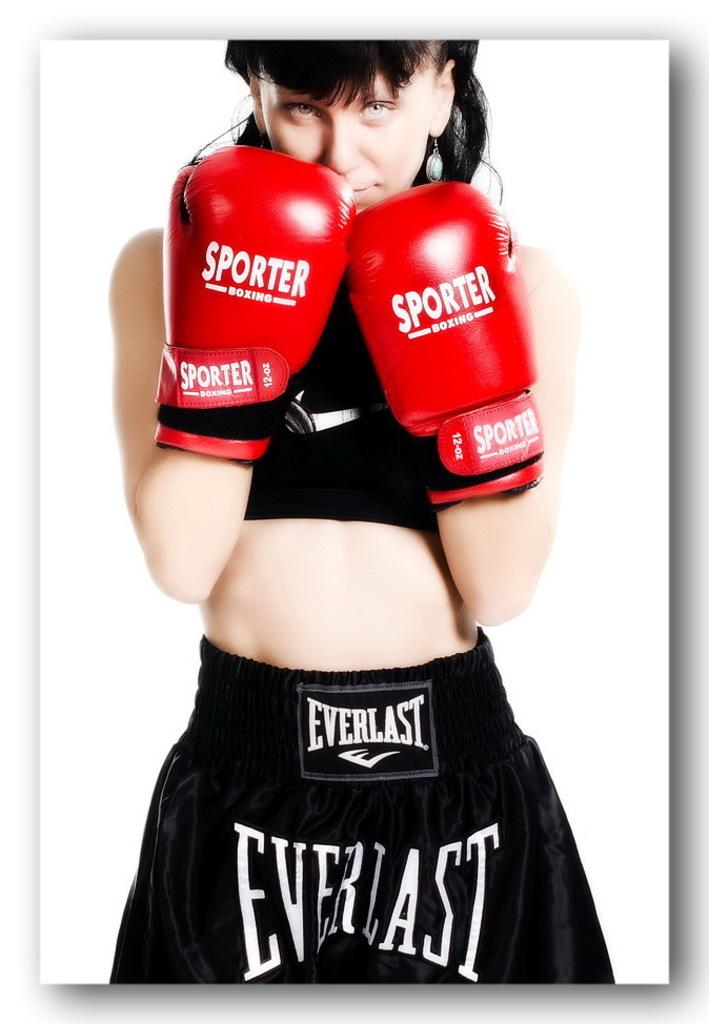<image>
Create a compact narrative representing the image presented. female boxer wearing everlast trunks and red sporter boxing gloves 